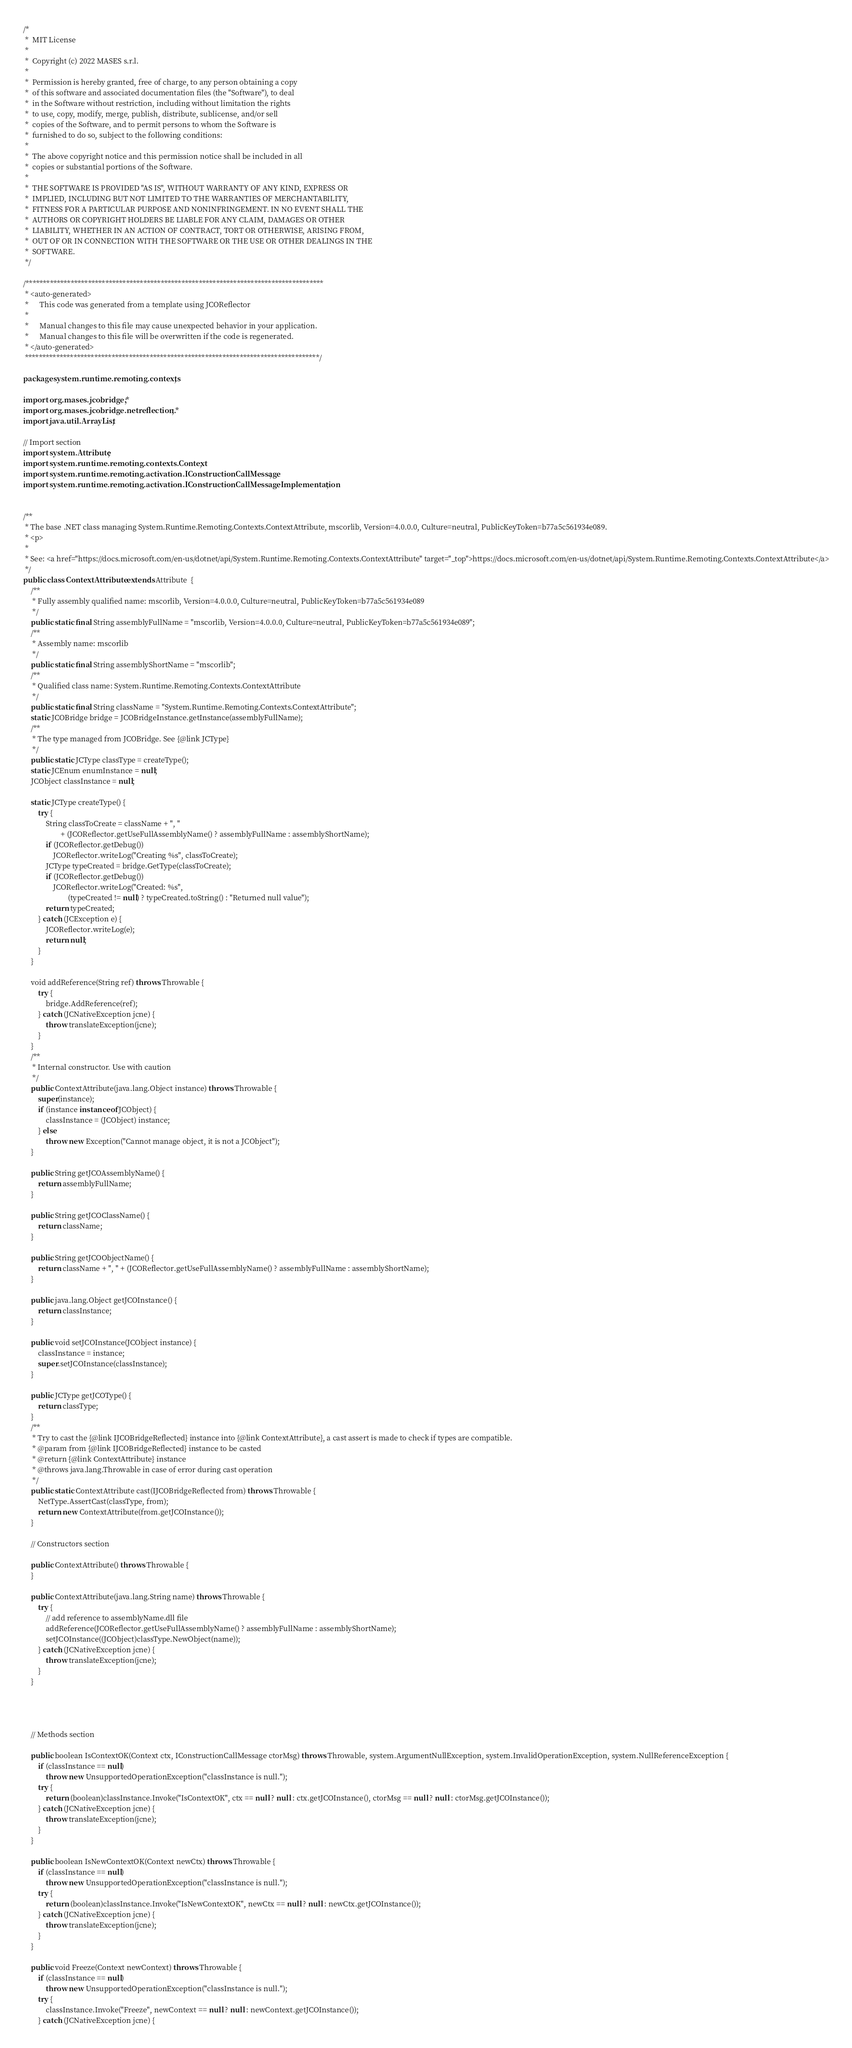Convert code to text. <code><loc_0><loc_0><loc_500><loc_500><_Java_>/*
 *  MIT License
 *
 *  Copyright (c) 2022 MASES s.r.l.
 *
 *  Permission is hereby granted, free of charge, to any person obtaining a copy
 *  of this software and associated documentation files (the "Software"), to deal
 *  in the Software without restriction, including without limitation the rights
 *  to use, copy, modify, merge, publish, distribute, sublicense, and/or sell
 *  copies of the Software, and to permit persons to whom the Software is
 *  furnished to do so, subject to the following conditions:
 *
 *  The above copyright notice and this permission notice shall be included in all
 *  copies or substantial portions of the Software.
 *
 *  THE SOFTWARE IS PROVIDED "AS IS", WITHOUT WARRANTY OF ANY KIND, EXPRESS OR
 *  IMPLIED, INCLUDING BUT NOT LIMITED TO THE WARRANTIES OF MERCHANTABILITY,
 *  FITNESS FOR A PARTICULAR PURPOSE AND NONINFRINGEMENT. IN NO EVENT SHALL THE
 *  AUTHORS OR COPYRIGHT HOLDERS BE LIABLE FOR ANY CLAIM, DAMAGES OR OTHER
 *  LIABILITY, WHETHER IN AN ACTION OF CONTRACT, TORT OR OTHERWISE, ARISING FROM,
 *  OUT OF OR IN CONNECTION WITH THE SOFTWARE OR THE USE OR OTHER DEALINGS IN THE
 *  SOFTWARE.
 */

/**************************************************************************************
 * <auto-generated>
 *      This code was generated from a template using JCOReflector
 * 
 *      Manual changes to this file may cause unexpected behavior in your application.
 *      Manual changes to this file will be overwritten if the code is regenerated.
 * </auto-generated>
 *************************************************************************************/

package system.runtime.remoting.contexts;

import org.mases.jcobridge.*;
import org.mases.jcobridge.netreflection.*;
import java.util.ArrayList;

// Import section
import system.Attribute;
import system.runtime.remoting.contexts.Context;
import system.runtime.remoting.activation.IConstructionCallMessage;
import system.runtime.remoting.activation.IConstructionCallMessageImplementation;


/**
 * The base .NET class managing System.Runtime.Remoting.Contexts.ContextAttribute, mscorlib, Version=4.0.0.0, Culture=neutral, PublicKeyToken=b77a5c561934e089.
 * <p>
 * 
 * See: <a href="https://docs.microsoft.com/en-us/dotnet/api/System.Runtime.Remoting.Contexts.ContextAttribute" target="_top">https://docs.microsoft.com/en-us/dotnet/api/System.Runtime.Remoting.Contexts.ContextAttribute</a>
 */
public class ContextAttribute extends Attribute  {
    /**
     * Fully assembly qualified name: mscorlib, Version=4.0.0.0, Culture=neutral, PublicKeyToken=b77a5c561934e089
     */
    public static final String assemblyFullName = "mscorlib, Version=4.0.0.0, Culture=neutral, PublicKeyToken=b77a5c561934e089";
    /**
     * Assembly name: mscorlib
     */
    public static final String assemblyShortName = "mscorlib";
    /**
     * Qualified class name: System.Runtime.Remoting.Contexts.ContextAttribute
     */
    public static final String className = "System.Runtime.Remoting.Contexts.ContextAttribute";
    static JCOBridge bridge = JCOBridgeInstance.getInstance(assemblyFullName);
    /**
     * The type managed from JCOBridge. See {@link JCType}
     */
    public static JCType classType = createType();
    static JCEnum enumInstance = null;
    JCObject classInstance = null;

    static JCType createType() {
        try {
            String classToCreate = className + ", "
                    + (JCOReflector.getUseFullAssemblyName() ? assemblyFullName : assemblyShortName);
            if (JCOReflector.getDebug())
                JCOReflector.writeLog("Creating %s", classToCreate);
            JCType typeCreated = bridge.GetType(classToCreate);
            if (JCOReflector.getDebug())
                JCOReflector.writeLog("Created: %s",
                        (typeCreated != null) ? typeCreated.toString() : "Returned null value");
            return typeCreated;
        } catch (JCException e) {
            JCOReflector.writeLog(e);
            return null;
        }
    }

    void addReference(String ref) throws Throwable {
        try {
            bridge.AddReference(ref);
        } catch (JCNativeException jcne) {
            throw translateException(jcne);
        }
    }
    /**
     * Internal constructor. Use with caution 
     */
    public ContextAttribute(java.lang.Object instance) throws Throwable {
        super(instance);
        if (instance instanceof JCObject) {
            classInstance = (JCObject) instance;
        } else
            throw new Exception("Cannot manage object, it is not a JCObject");
    }

    public String getJCOAssemblyName() {
        return assemblyFullName;
    }

    public String getJCOClassName() {
        return className;
    }

    public String getJCOObjectName() {
        return className + ", " + (JCOReflector.getUseFullAssemblyName() ? assemblyFullName : assemblyShortName);
    }

    public java.lang.Object getJCOInstance() {
        return classInstance;
    }

    public void setJCOInstance(JCObject instance) {
        classInstance = instance;
        super.setJCOInstance(classInstance);
    }

    public JCType getJCOType() {
        return classType;
    }
    /**
     * Try to cast the {@link IJCOBridgeReflected} instance into {@link ContextAttribute}, a cast assert is made to check if types are compatible.
     * @param from {@link IJCOBridgeReflected} instance to be casted
     * @return {@link ContextAttribute} instance
     * @throws java.lang.Throwable in case of error during cast operation
     */
    public static ContextAttribute cast(IJCOBridgeReflected from) throws Throwable {
        NetType.AssertCast(classType, from);
        return new ContextAttribute(from.getJCOInstance());
    }

    // Constructors section
    
    public ContextAttribute() throws Throwable {
    }

    public ContextAttribute(java.lang.String name) throws Throwable {
        try {
            // add reference to assemblyName.dll file
            addReference(JCOReflector.getUseFullAssemblyName() ? assemblyFullName : assemblyShortName);
            setJCOInstance((JCObject)classType.NewObject(name));
        } catch (JCNativeException jcne) {
            throw translateException(jcne);
        }
    }



    
    // Methods section
    
    public boolean IsContextOK(Context ctx, IConstructionCallMessage ctorMsg) throws Throwable, system.ArgumentNullException, system.InvalidOperationException, system.NullReferenceException {
        if (classInstance == null)
            throw new UnsupportedOperationException("classInstance is null.");
        try {
            return (boolean)classInstance.Invoke("IsContextOK", ctx == null ? null : ctx.getJCOInstance(), ctorMsg == null ? null : ctorMsg.getJCOInstance());
        } catch (JCNativeException jcne) {
            throw translateException(jcne);
        }
    }

    public boolean IsNewContextOK(Context newCtx) throws Throwable {
        if (classInstance == null)
            throw new UnsupportedOperationException("classInstance is null.");
        try {
            return (boolean)classInstance.Invoke("IsNewContextOK", newCtx == null ? null : newCtx.getJCOInstance());
        } catch (JCNativeException jcne) {
            throw translateException(jcne);
        }
    }

    public void Freeze(Context newContext) throws Throwable {
        if (classInstance == null)
            throw new UnsupportedOperationException("classInstance is null.");
        try {
            classInstance.Invoke("Freeze", newContext == null ? null : newContext.getJCOInstance());
        } catch (JCNativeException jcne) {</code> 